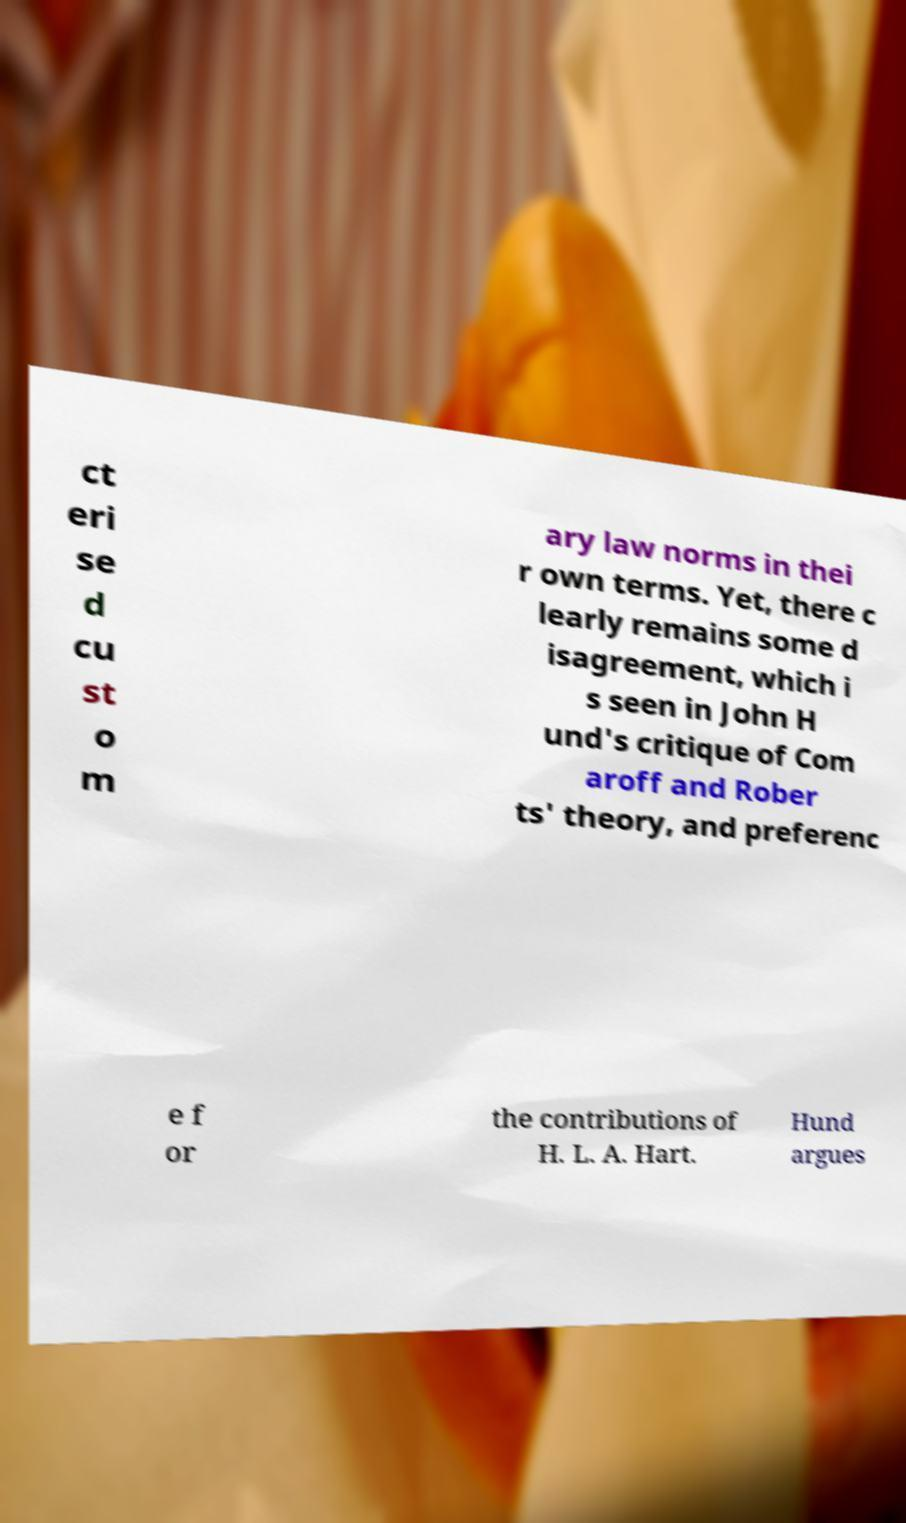Can you read and provide the text displayed in the image?This photo seems to have some interesting text. Can you extract and type it out for me? ct eri se d cu st o m ary law norms in thei r own terms. Yet, there c learly remains some d isagreement, which i s seen in John H und's critique of Com aroff and Rober ts' theory, and preferenc e f or the contributions of H. L. A. Hart. Hund argues 